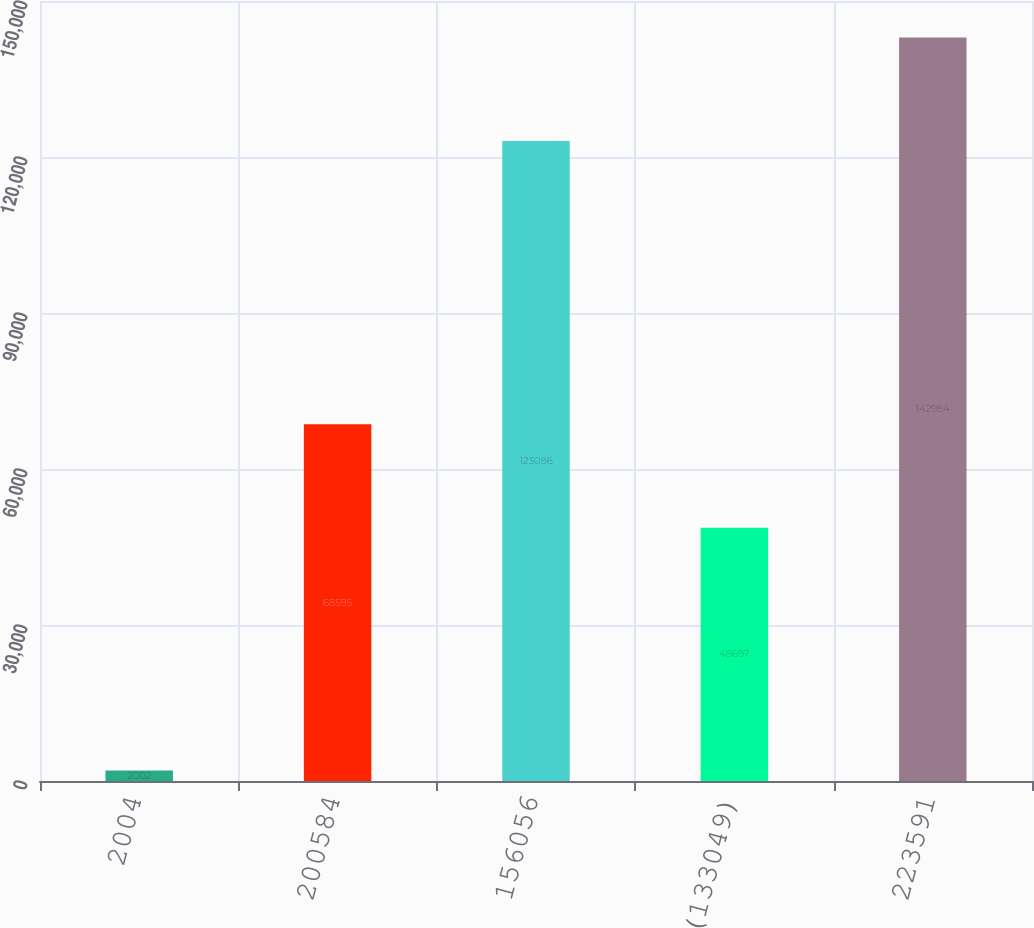<chart> <loc_0><loc_0><loc_500><loc_500><bar_chart><fcel>2004<fcel>200584<fcel>156056<fcel>(133049)<fcel>223591<nl><fcel>2002<fcel>68595<fcel>123086<fcel>48697<fcel>142984<nl></chart> 